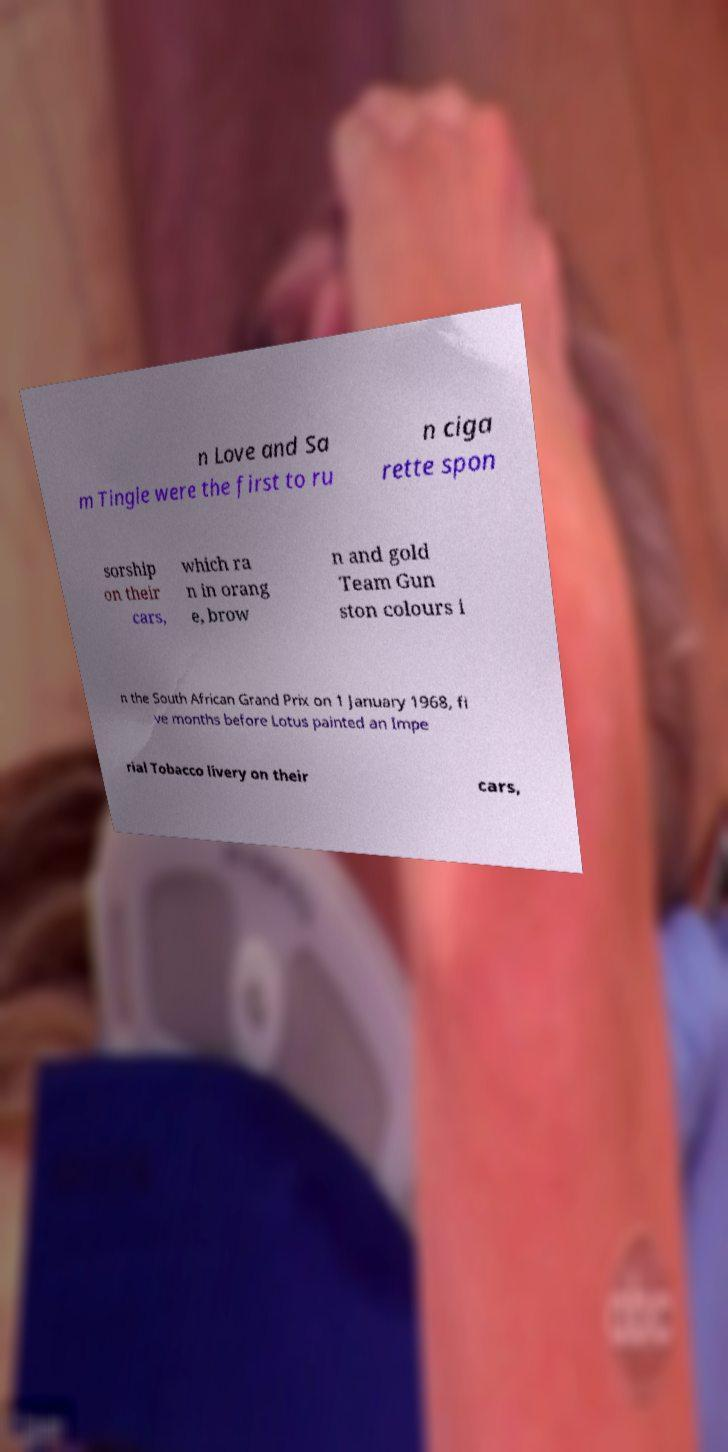Can you accurately transcribe the text from the provided image for me? n Love and Sa m Tingle were the first to ru n ciga rette spon sorship on their cars, which ra n in orang e, brow n and gold Team Gun ston colours i n the South African Grand Prix on 1 January 1968, fi ve months before Lotus painted an Impe rial Tobacco livery on their cars, 